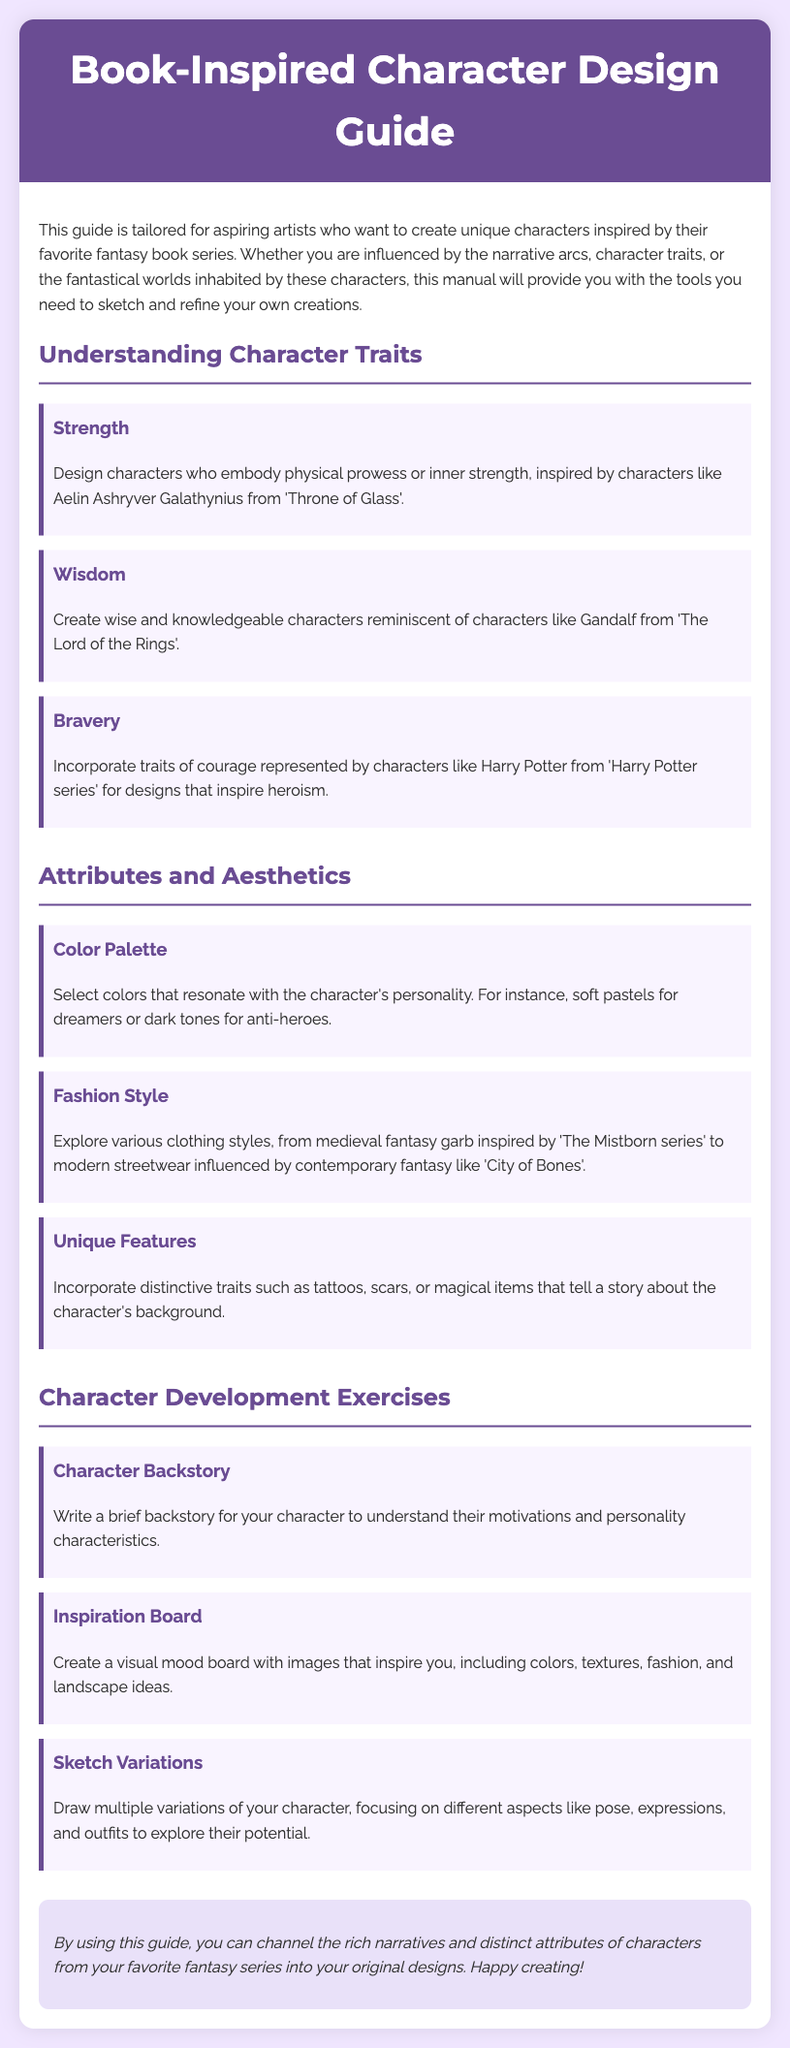What is the title of the guide? The title of the guide is found in the header section at the top of the document.
Answer: Book-Inspired Character Design Guide Who is an example of a character that embodies strength? The guide provides a specific character as an example for strength, which is mentioned in the traits section.
Answer: Aelin Ashryver Galathynius What fashion style is inspired by 'The Mistborn series'? The manual describes particular clothing styles in the attributes section, specifically referring to one series.
Answer: Medieval fantasy garb How many character development exercises are mentioned? The number of exercises can be found by counting the list in the exercises section of the document.
Answer: Three What is the purpose of the inspiration board exercise? The guide describes the goal of this exercise in the character development exercises section.
Answer: To create a visual mood board What color palette is suggested for dreamer characters? The guide specifies the color suggestions in the attributes section for various character personalities.
Answer: Soft pastels Which character is referenced as an example of wisdom? An example character is provided in the traits section that represents wisdom.
Answer: Gandalf What type of features are recommended to make a character unique? The document outlines specific features to consider for character uniqueness in the attributes section.
Answer: Distinctive traits such as tattoos, scars, or magical items 